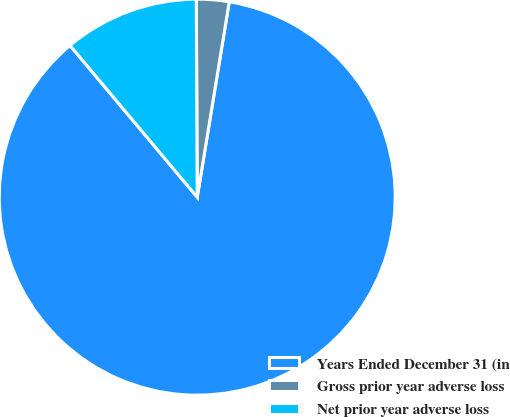Convert chart to OTSL. <chart><loc_0><loc_0><loc_500><loc_500><pie_chart><fcel>Years Ended December 31 (in<fcel>Gross prior year adverse loss<fcel>Net prior year adverse loss<nl><fcel>86.31%<fcel>2.66%<fcel>11.03%<nl></chart> 